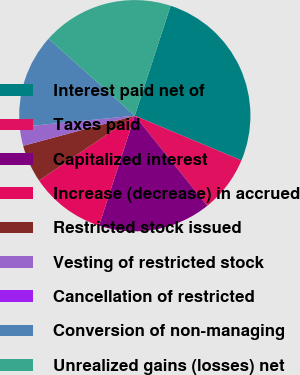<chart> <loc_0><loc_0><loc_500><loc_500><pie_chart><fcel>Interest paid net of<fcel>Taxes paid<fcel>Capitalized interest<fcel>Increase (decrease) in accrued<fcel>Restricted stock issued<fcel>Vesting of restricted stock<fcel>Cancellation of restricted<fcel>Conversion of non-managing<fcel>Unrealized gains (losses) net<nl><fcel>26.31%<fcel>7.9%<fcel>15.79%<fcel>10.53%<fcel>5.27%<fcel>2.64%<fcel>0.0%<fcel>13.16%<fcel>18.42%<nl></chart> 